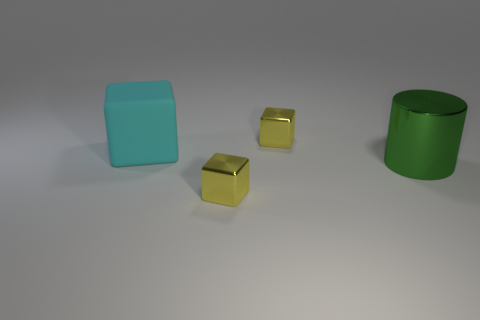Do the cube that is in front of the cyan matte object and the big cylinder have the same size? No, they do not. The cube in front of the cyan object appears smaller in size relative to the larger green cylinder, indicating that the two are not the same size. When we assess objects in an image, the visual cues such as their relative dimensions and the perspective offered by their placement within the scene contribute to our understanding of their size. 